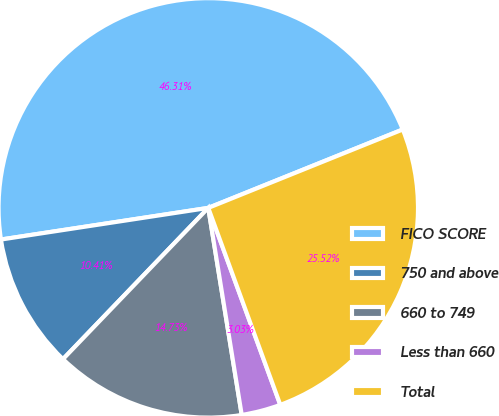<chart> <loc_0><loc_0><loc_500><loc_500><pie_chart><fcel>FICO SCORE<fcel>750 and above<fcel>660 to 749<fcel>Less than 660<fcel>Total<nl><fcel>46.31%<fcel>10.41%<fcel>14.73%<fcel>3.03%<fcel>25.52%<nl></chart> 